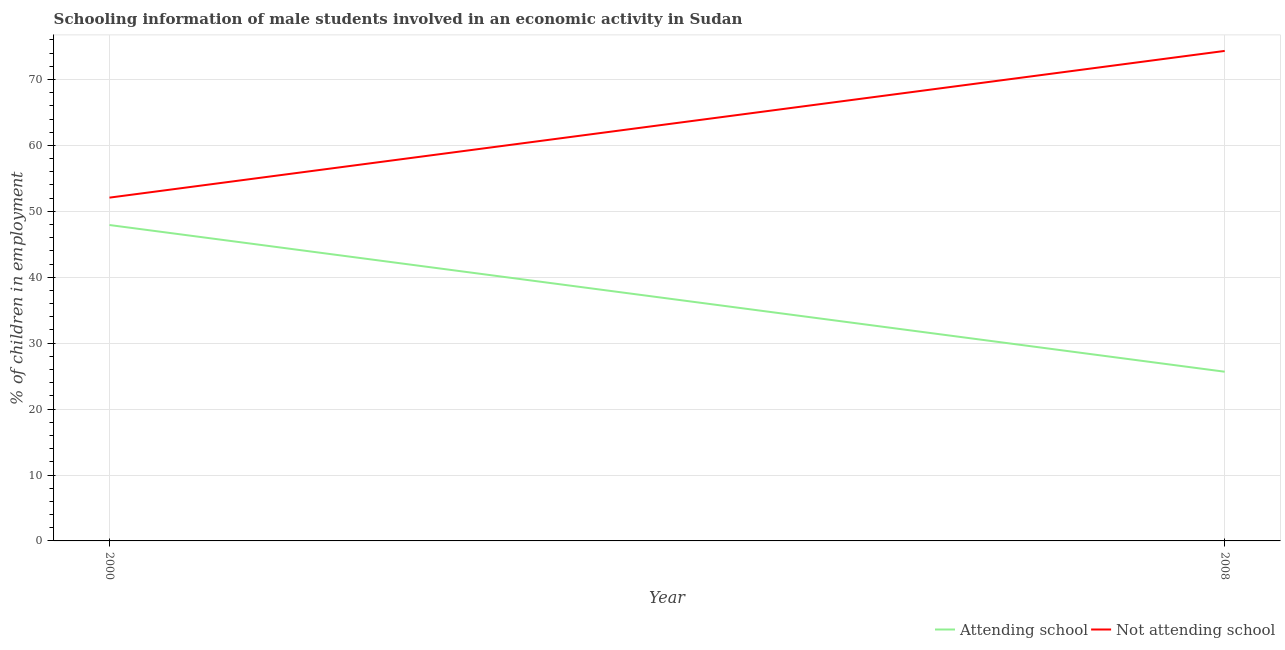How many different coloured lines are there?
Your answer should be very brief. 2. Does the line corresponding to percentage of employed males who are attending school intersect with the line corresponding to percentage of employed males who are not attending school?
Your answer should be compact. No. What is the percentage of employed males who are attending school in 2008?
Provide a short and direct response. 25.67. Across all years, what is the maximum percentage of employed males who are not attending school?
Offer a very short reply. 74.33. Across all years, what is the minimum percentage of employed males who are not attending school?
Make the answer very short. 52.08. In which year was the percentage of employed males who are not attending school maximum?
Ensure brevity in your answer.  2008. What is the total percentage of employed males who are not attending school in the graph?
Offer a terse response. 126.41. What is the difference between the percentage of employed males who are attending school in 2000 and that in 2008?
Ensure brevity in your answer.  22.26. What is the difference between the percentage of employed males who are not attending school in 2008 and the percentage of employed males who are attending school in 2000?
Your answer should be compact. 26.41. What is the average percentage of employed males who are not attending school per year?
Offer a very short reply. 63.21. In the year 2000, what is the difference between the percentage of employed males who are not attending school and percentage of employed males who are attending school?
Give a very brief answer. 4.16. In how many years, is the percentage of employed males who are not attending school greater than 62 %?
Give a very brief answer. 1. What is the ratio of the percentage of employed males who are not attending school in 2000 to that in 2008?
Your response must be concise. 0.7. How many lines are there?
Make the answer very short. 2. Are the values on the major ticks of Y-axis written in scientific E-notation?
Your answer should be compact. No. Does the graph contain any zero values?
Make the answer very short. No. Does the graph contain grids?
Keep it short and to the point. Yes. How many legend labels are there?
Your response must be concise. 2. How are the legend labels stacked?
Offer a terse response. Horizontal. What is the title of the graph?
Your answer should be compact. Schooling information of male students involved in an economic activity in Sudan. Does "Goods" appear as one of the legend labels in the graph?
Your answer should be compact. No. What is the label or title of the X-axis?
Your answer should be very brief. Year. What is the label or title of the Y-axis?
Ensure brevity in your answer.  % of children in employment. What is the % of children in employment in Attending school in 2000?
Keep it short and to the point. 47.92. What is the % of children in employment of Not attending school in 2000?
Your answer should be very brief. 52.08. What is the % of children in employment of Attending school in 2008?
Provide a short and direct response. 25.67. What is the % of children in employment of Not attending school in 2008?
Your response must be concise. 74.33. Across all years, what is the maximum % of children in employment in Attending school?
Ensure brevity in your answer.  47.92. Across all years, what is the maximum % of children in employment of Not attending school?
Provide a succinct answer. 74.33. Across all years, what is the minimum % of children in employment of Attending school?
Your answer should be very brief. 25.67. Across all years, what is the minimum % of children in employment in Not attending school?
Offer a terse response. 52.08. What is the total % of children in employment of Attending school in the graph?
Your answer should be compact. 73.59. What is the total % of children in employment in Not attending school in the graph?
Provide a succinct answer. 126.41. What is the difference between the % of children in employment in Attending school in 2000 and that in 2008?
Offer a very short reply. 22.26. What is the difference between the % of children in employment in Not attending school in 2000 and that in 2008?
Your answer should be compact. -22.26. What is the difference between the % of children in employment in Attending school in 2000 and the % of children in employment in Not attending school in 2008?
Your answer should be very brief. -26.41. What is the average % of children in employment in Attending school per year?
Your answer should be very brief. 36.79. What is the average % of children in employment of Not attending school per year?
Make the answer very short. 63.21. In the year 2000, what is the difference between the % of children in employment of Attending school and % of children in employment of Not attending school?
Your answer should be very brief. -4.16. In the year 2008, what is the difference between the % of children in employment of Attending school and % of children in employment of Not attending school?
Ensure brevity in your answer.  -48.67. What is the ratio of the % of children in employment of Attending school in 2000 to that in 2008?
Provide a short and direct response. 1.87. What is the ratio of the % of children in employment in Not attending school in 2000 to that in 2008?
Your answer should be compact. 0.7. What is the difference between the highest and the second highest % of children in employment of Attending school?
Give a very brief answer. 22.26. What is the difference between the highest and the second highest % of children in employment of Not attending school?
Provide a succinct answer. 22.26. What is the difference between the highest and the lowest % of children in employment in Attending school?
Your answer should be compact. 22.26. What is the difference between the highest and the lowest % of children in employment in Not attending school?
Offer a terse response. 22.26. 